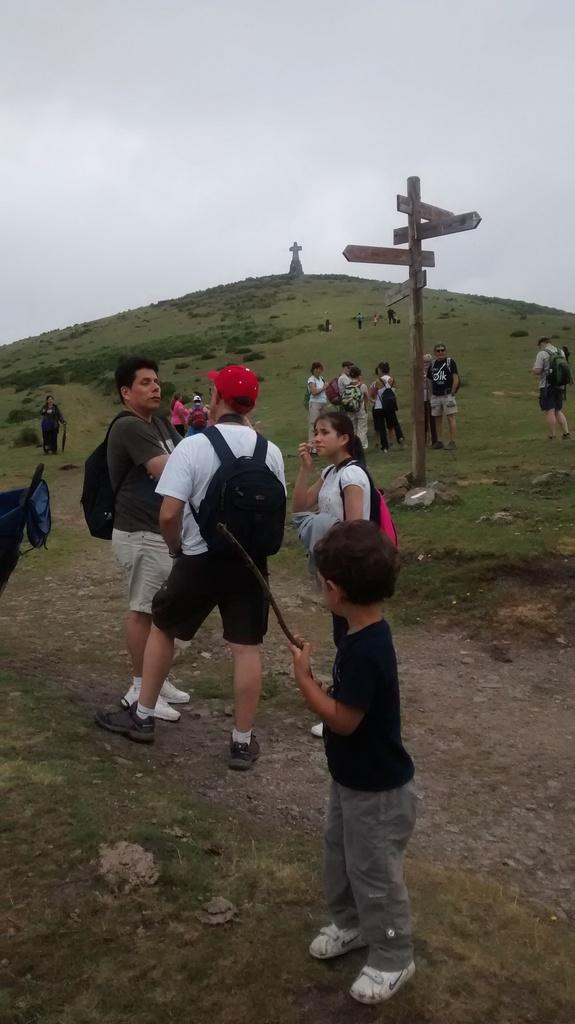What is happening in the image? There is a group of people standing in the image. What can be seen near the group of people? There are direction boards in the image, and they are near a pole. What is visible on the hill in the image? There is a holy cross on a hill in the image. What is visible in the background of the image? The sky is visible in the background of the image. What is the opinion of the girl in the image about the direction boards? There is no girl present in the image, so it is not possible to determine her opinion about the direction boards. 